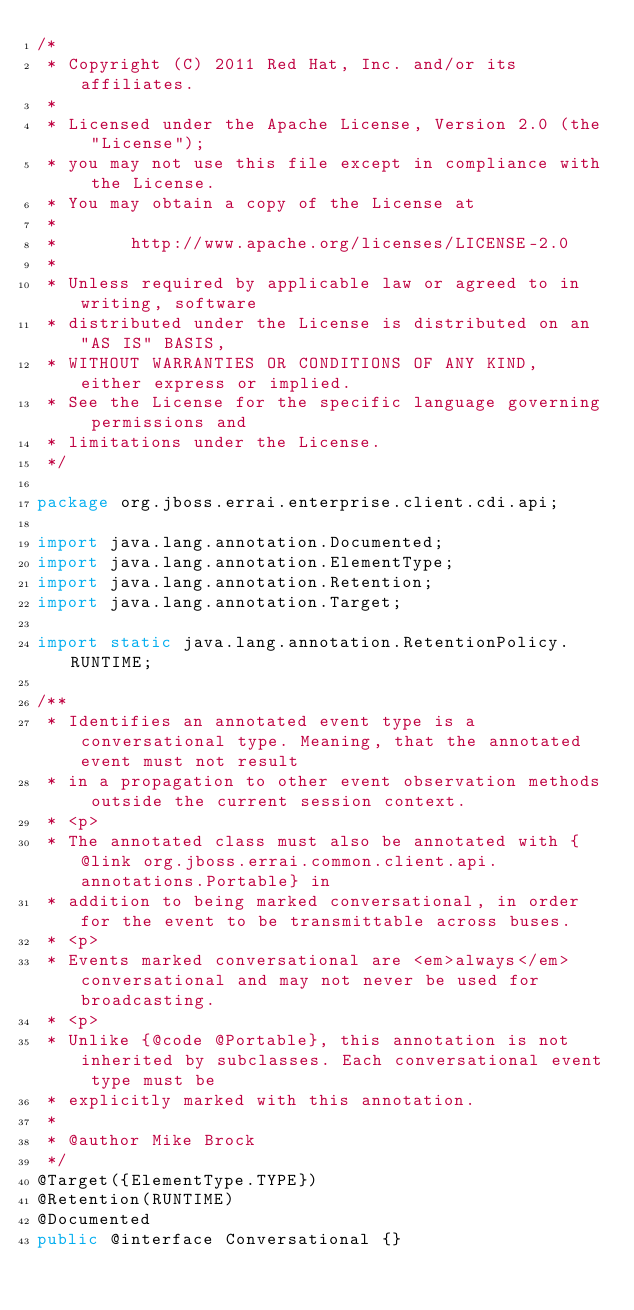Convert code to text. <code><loc_0><loc_0><loc_500><loc_500><_Java_>/*
 * Copyright (C) 2011 Red Hat, Inc. and/or its affiliates.
 *
 * Licensed under the Apache License, Version 2.0 (the "License");
 * you may not use this file except in compliance with the License.
 * You may obtain a copy of the License at
 *
 *       http://www.apache.org/licenses/LICENSE-2.0
 *
 * Unless required by applicable law or agreed to in writing, software
 * distributed under the License is distributed on an "AS IS" BASIS,
 * WITHOUT WARRANTIES OR CONDITIONS OF ANY KIND, either express or implied.
 * See the License for the specific language governing permissions and
 * limitations under the License.
 */

package org.jboss.errai.enterprise.client.cdi.api;

import java.lang.annotation.Documented;
import java.lang.annotation.ElementType;
import java.lang.annotation.Retention;
import java.lang.annotation.Target;

import static java.lang.annotation.RetentionPolicy.RUNTIME;

/**
 * Identifies an annotated event type is a conversational type. Meaning, that the annotated event must not result
 * in a propagation to other event observation methods outside the current session context.
 * <p>
 * The annotated class must also be annotated with {@link org.jboss.errai.common.client.api.annotations.Portable} in
 * addition to being marked conversational, in order for the event to be transmittable across buses.
 * <p>
 * Events marked conversational are <em>always</em> conversational and may not never be used for broadcasting.
 * <p>
 * Unlike {@code @Portable}, this annotation is not inherited by subclasses. Each conversational event type must be
 * explicitly marked with this annotation.
 *
 * @author Mike Brock
 */
@Target({ElementType.TYPE})
@Retention(RUNTIME)
@Documented
public @interface Conversational {}
</code> 